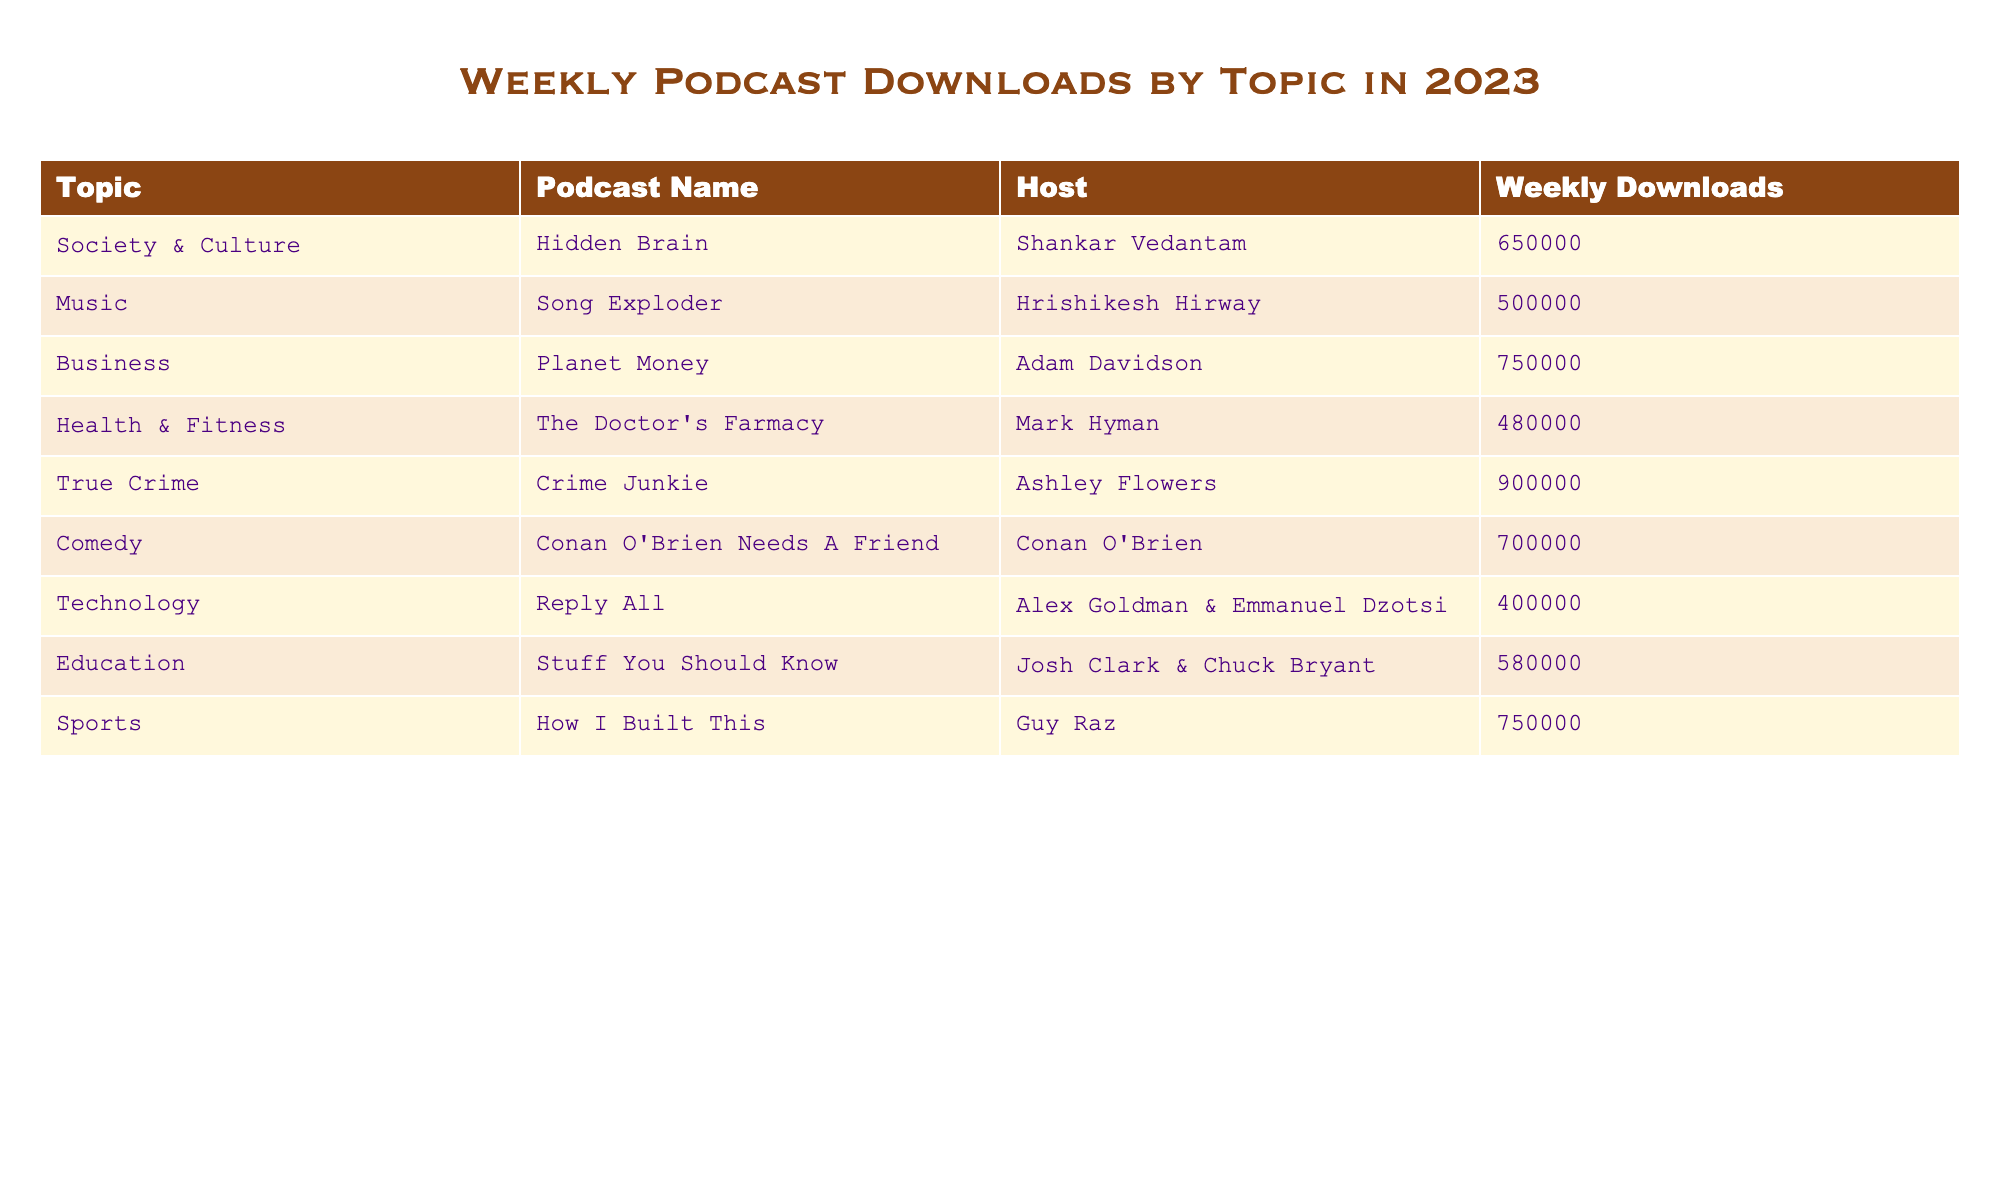What is the podcast with the highest weekly downloads? The highest value in the 'Weekly Downloads' column is 900,000, which corresponds to the podcast 'Crime Junkie'.
Answer: Crime Junkie How many downloads does 'The Doctor's Farmacy' have? The number of weekly downloads for 'The Doctor's Farmacy' is directly stated in the table, which shows it has 480,000 downloads.
Answer: 480,000 What topic has the lowest number of weekly downloads? By inspecting the 'Weekly Downloads' column, we see that 'Reply All' under the 'Technology' topic has the lowest downloads with 400,000.
Answer: Technology What is the sum of weekly downloads for all podcasts listed? Adding the weekly downloads from each podcast, (650,000 + 500,000 + 750,000 + 480,000 + 900,000 + 700,000 + 400,000 + 580,000 + 750,000) equals 5,710,000.
Answer: 5,710,000 How many podcasts in the 'Comedy' topic have more than 600,000 downloads? There's only one podcast listed under 'Comedy', which is 'Conan O'Brien Needs A Friend' with 700,000 downloads, fulfilling the condition, so the answer is one.
Answer: 1 What is the average number of downloads for podcasts in the 'Business' and 'Sports' categories? The downloads for 'Planet Money' in Business is 750,000 and 'How I Built This' in Sports is also 750,000. The average is calculated as (750,000 + 750,000) / 2 = 750,000.
Answer: 750,000 Which podcast type, Society & Culture or Music, has more downloads in total? Society & Culture has 'Hidden Brain' with 650,000 downloads, and Music has 'Song Exploder' with 500,000 downloads. Comparing the totals, Society & Culture (650,000) has more than Music (500,000).
Answer: Society & Culture Is 'Stuff You Should Know' the only educational podcast listed? Checking the table, 'Stuff You Should Know' is the only podcast listed under 'Education', confirming that it is indeed the sole educational podcast shown.
Answer: Yes How many downloads do podcasts with the topic of 'Health & Fitness' receive compared to those under 'True Crime'? 'The Doctor's Farmacy' in Health & Fitness has 480,000 downloads, while 'Crime Junkie' in True Crime has 900,000. The latter exceeds the former, with a difference of 420,000.
Answer: 420,000 difference Are there any podcasts in the Technology category with more than 500,000 downloads? The only podcast in the Technology category is 'Reply All' with 400,000 downloads, which does not exceed 500,000.
Answer: No 